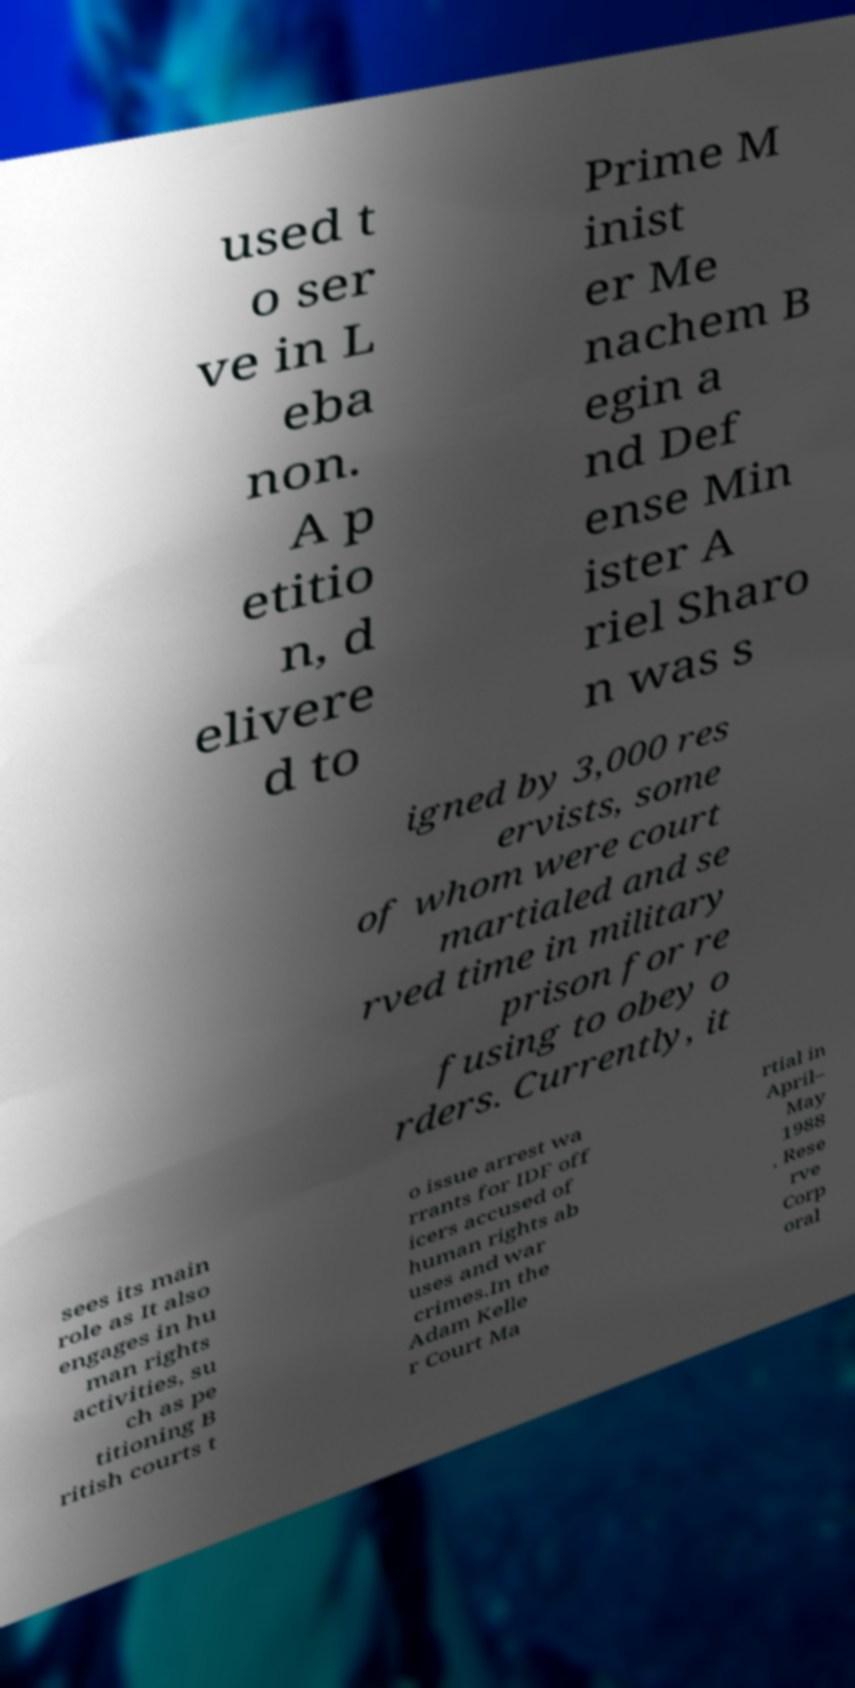Could you assist in decoding the text presented in this image and type it out clearly? used t o ser ve in L eba non. A p etitio n, d elivere d to Prime M inist er Me nachem B egin a nd Def ense Min ister A riel Sharo n was s igned by 3,000 res ervists, some of whom were court martialed and se rved time in military prison for re fusing to obey o rders. Currently, it sees its main role as It also engages in hu man rights activities, su ch as pe titioning B ritish courts t o issue arrest wa rrants for IDF off icers accused of human rights ab uses and war crimes.In the Adam Kelle r Court Ma rtial in April– May 1988 , Rese rve Corp oral 